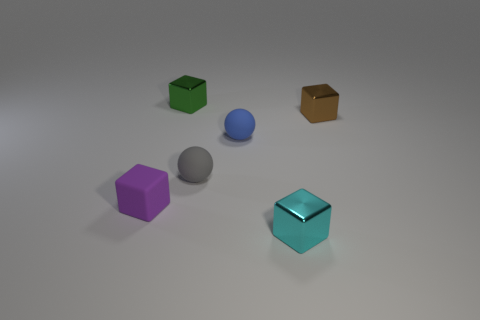What is the shape of the small shiny object to the left of the metal object that is in front of the tiny cube left of the green cube?
Provide a succinct answer. Cube. Is the shape of the tiny metallic object to the left of the tiny blue matte ball the same as the small metal thing that is in front of the tiny brown block?
Your response must be concise. Yes. What number of other objects are there of the same material as the tiny gray thing?
Your answer should be compact. 2. What is the shape of the small brown object that is made of the same material as the cyan block?
Your response must be concise. Cube. Do the rubber cube and the brown metal thing have the same size?
Offer a terse response. Yes. There is a thing on the right side of the tiny shiny block that is in front of the tiny purple rubber cube; what is its size?
Your answer should be compact. Small. How many blocks are small green things or tiny purple objects?
Keep it short and to the point. 2. Is the size of the cyan object the same as the shiny cube on the right side of the cyan shiny object?
Your answer should be very brief. Yes. Is the number of gray rubber balls right of the cyan metallic object greater than the number of tiny green shiny things?
Your answer should be very brief. No. There is a cyan object that is the same material as the small green block; what is its size?
Your answer should be compact. Small. 